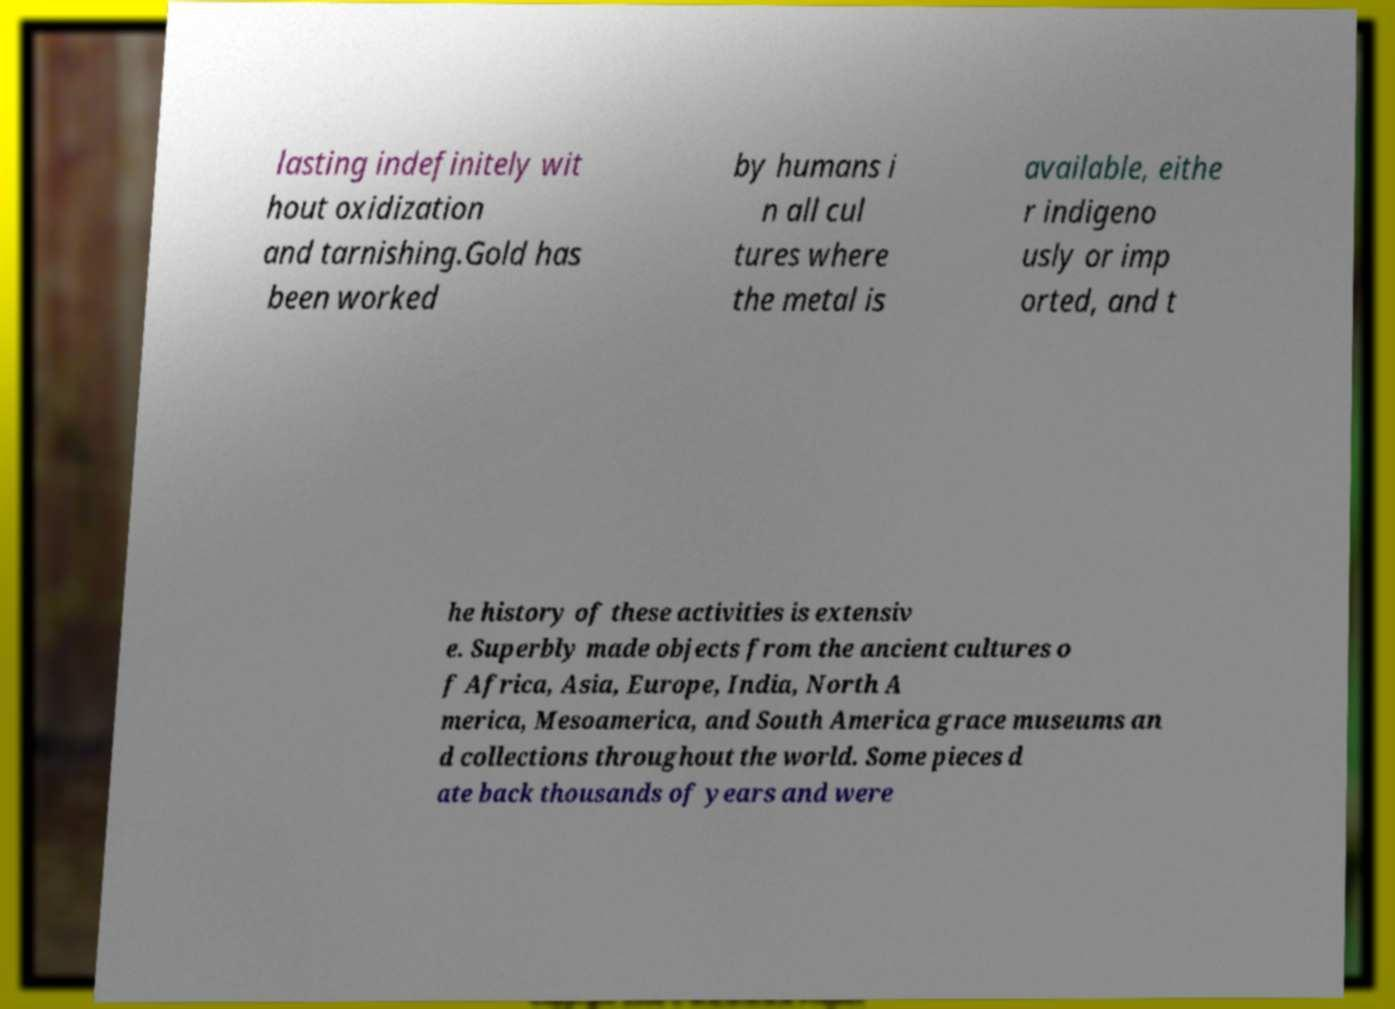Please identify and transcribe the text found in this image. lasting indefinitely wit hout oxidization and tarnishing.Gold has been worked by humans i n all cul tures where the metal is available, eithe r indigeno usly or imp orted, and t he history of these activities is extensiv e. Superbly made objects from the ancient cultures o f Africa, Asia, Europe, India, North A merica, Mesoamerica, and South America grace museums an d collections throughout the world. Some pieces d ate back thousands of years and were 